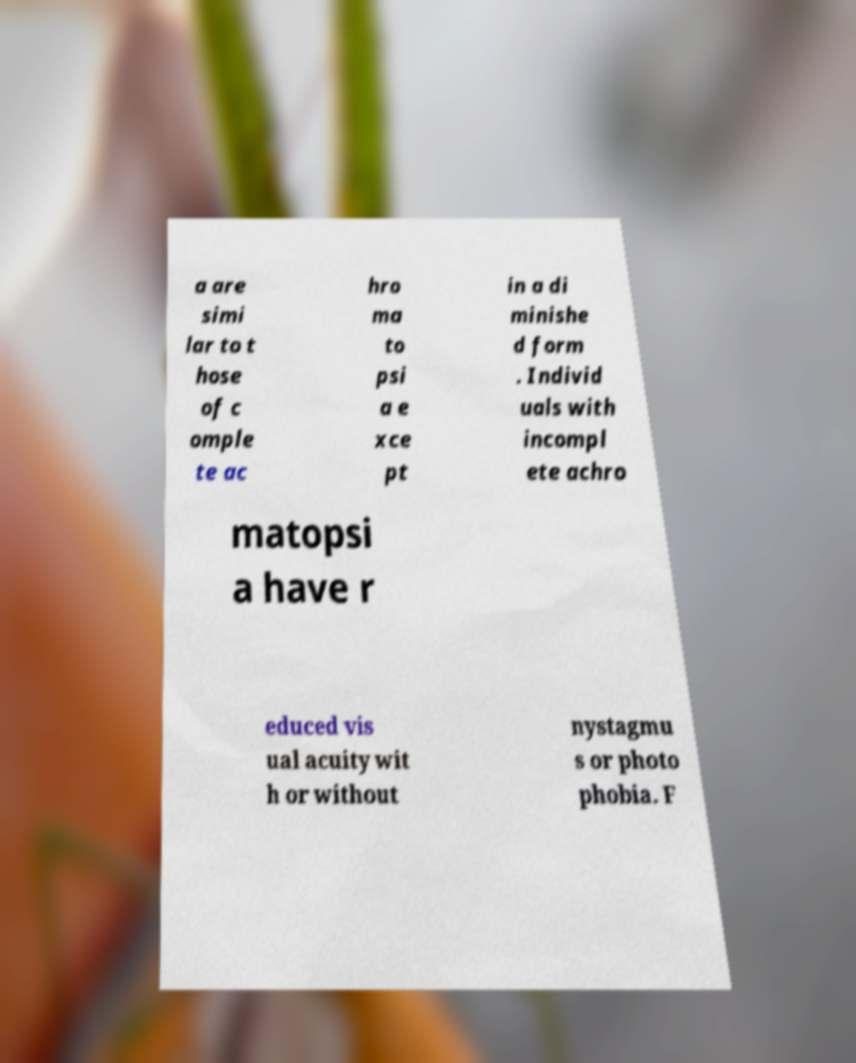For documentation purposes, I need the text within this image transcribed. Could you provide that? a are simi lar to t hose of c omple te ac hro ma to psi a e xce pt in a di minishe d form . Individ uals with incompl ete achro matopsi a have r educed vis ual acuity wit h or without nystagmu s or photo phobia. F 